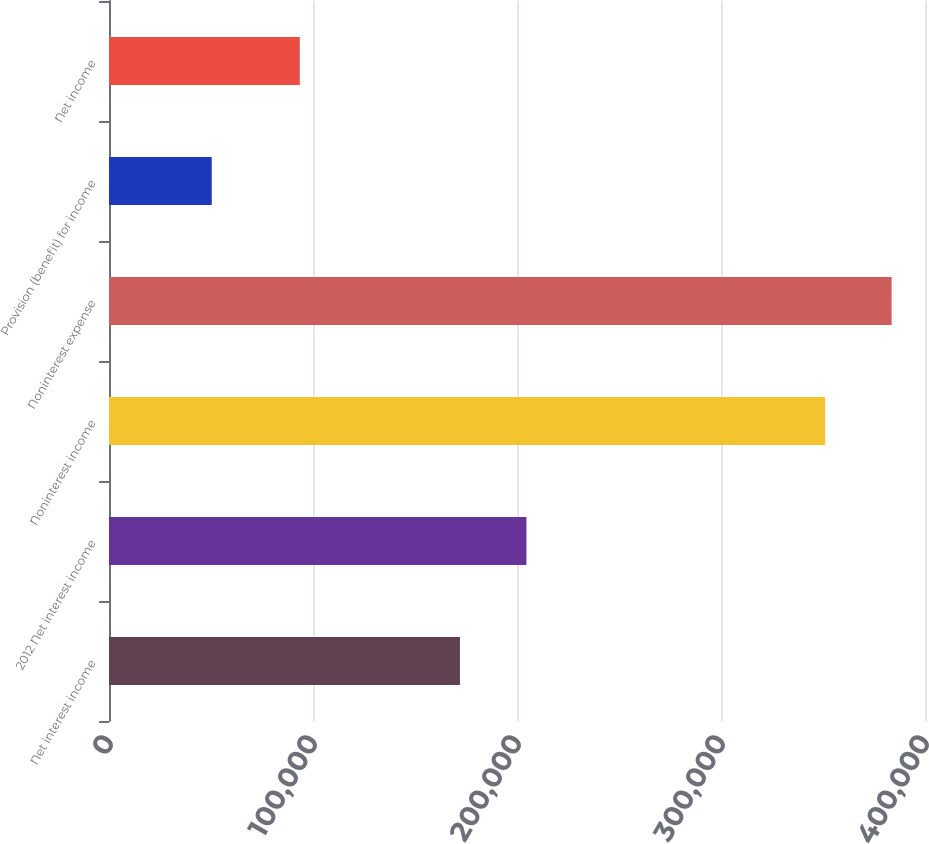Convert chart to OTSL. <chart><loc_0><loc_0><loc_500><loc_500><bar_chart><fcel>Net interest income<fcel>2012 Net interest income<fcel>Noninterest income<fcel>Noninterest expense<fcel>Provision (benefit) for income<fcel>Net income<nl><fcel>172033<fcel>204620<fcel>351057<fcel>383644<fcel>50365<fcel>93534<nl></chart> 